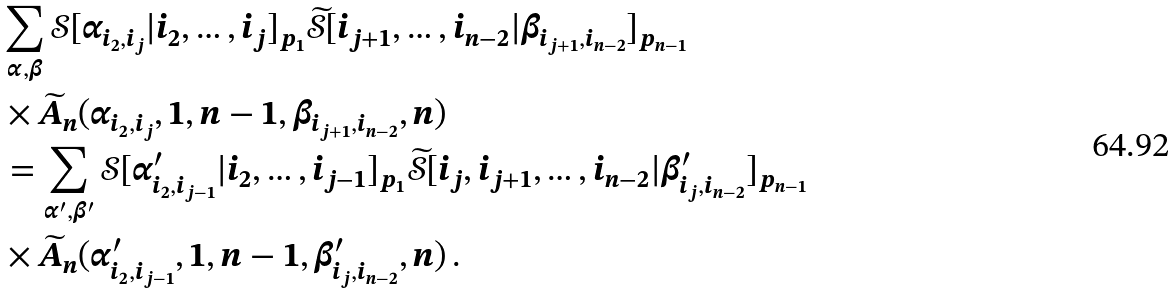<formula> <loc_0><loc_0><loc_500><loc_500>& \sum _ { \alpha , \beta } \mathcal { S } [ \alpha _ { i _ { 2 } , i _ { j } } | i _ { 2 } , \dots , i _ { j } ] _ { p _ { 1 } } \widetilde { \mathcal { S } } [ i _ { j + 1 } , \dots , i _ { n - 2 } | \beta _ { i _ { j + 1 } , i _ { n - 2 } } ] _ { p _ { n - 1 } } \\ & \times \widetilde { A } _ { n } ( \alpha _ { i _ { 2 } , i _ { j } } , 1 , n - 1 , \beta _ { i _ { j + 1 } , i _ { n - 2 } } , n ) \\ & = \sum _ { \alpha ^ { \prime } , \beta ^ { \prime } } \mathcal { S } [ \alpha ^ { \prime } _ { i _ { 2 } , i _ { j - 1 } } | i _ { 2 } , \dots , i _ { j - 1 } ] _ { p _ { 1 } } \widetilde { \mathcal { S } } [ i _ { j } , i _ { j + 1 } , \dots , i _ { n - 2 } | \beta ^ { \prime } _ { i _ { j } , i _ { n - 2 } } ] _ { p _ { n - 1 } } \\ & \times \widetilde { A } _ { n } ( \alpha ^ { \prime } _ { i _ { 2 } , i _ { j - 1 } } , 1 , n - 1 , \beta ^ { \prime } _ { i _ { j } , i _ { n - 2 } } , n ) \, .</formula> 